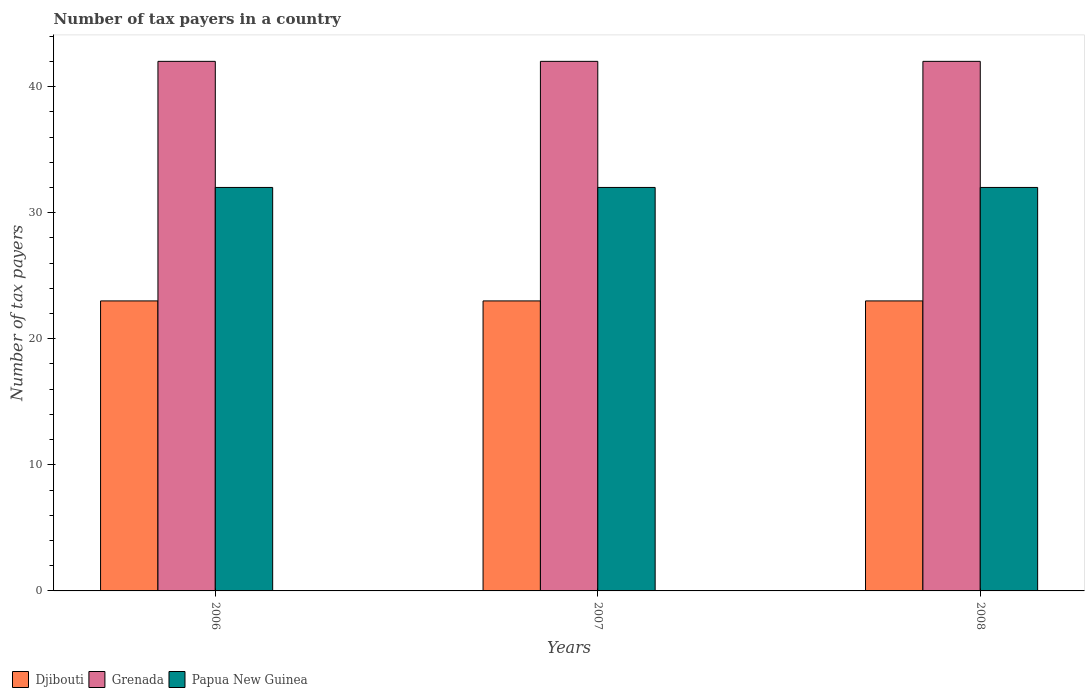How many different coloured bars are there?
Keep it short and to the point. 3. How many groups of bars are there?
Provide a short and direct response. 3. Are the number of bars per tick equal to the number of legend labels?
Offer a very short reply. Yes. Are the number of bars on each tick of the X-axis equal?
Keep it short and to the point. Yes. How many bars are there on the 3rd tick from the left?
Ensure brevity in your answer.  3. How many bars are there on the 1st tick from the right?
Make the answer very short. 3. In how many cases, is the number of bars for a given year not equal to the number of legend labels?
Provide a short and direct response. 0. What is the number of tax payers in in Djibouti in 2008?
Keep it short and to the point. 23. Across all years, what is the maximum number of tax payers in in Grenada?
Keep it short and to the point. 42. Across all years, what is the minimum number of tax payers in in Grenada?
Make the answer very short. 42. What is the total number of tax payers in in Papua New Guinea in the graph?
Ensure brevity in your answer.  96. What is the difference between the number of tax payers in in Grenada in 2008 and the number of tax payers in in Papua New Guinea in 2006?
Make the answer very short. 10. What is the average number of tax payers in in Papua New Guinea per year?
Provide a succinct answer. 32. In the year 2008, what is the difference between the number of tax payers in in Djibouti and number of tax payers in in Grenada?
Your response must be concise. -19. In how many years, is the number of tax payers in in Grenada greater than 42?
Offer a terse response. 0. What is the ratio of the number of tax payers in in Djibouti in 2006 to that in 2007?
Your response must be concise. 1. Is the difference between the number of tax payers in in Djibouti in 2007 and 2008 greater than the difference between the number of tax payers in in Grenada in 2007 and 2008?
Make the answer very short. No. What is the difference between the highest and the lowest number of tax payers in in Grenada?
Give a very brief answer. 0. What does the 3rd bar from the left in 2008 represents?
Offer a terse response. Papua New Guinea. What does the 1st bar from the right in 2006 represents?
Provide a succinct answer. Papua New Guinea. Is it the case that in every year, the sum of the number of tax payers in in Grenada and number of tax payers in in Djibouti is greater than the number of tax payers in in Papua New Guinea?
Make the answer very short. Yes. How many bars are there?
Keep it short and to the point. 9. Are all the bars in the graph horizontal?
Provide a short and direct response. No. Are the values on the major ticks of Y-axis written in scientific E-notation?
Make the answer very short. No. Where does the legend appear in the graph?
Keep it short and to the point. Bottom left. How many legend labels are there?
Your response must be concise. 3. What is the title of the graph?
Ensure brevity in your answer.  Number of tax payers in a country. What is the label or title of the Y-axis?
Provide a succinct answer. Number of tax payers. What is the Number of tax payers in Djibouti in 2006?
Provide a succinct answer. 23. What is the Number of tax payers in Grenada in 2006?
Offer a very short reply. 42. What is the Number of tax payers of Papua New Guinea in 2006?
Ensure brevity in your answer.  32. What is the Number of tax payers in Djibouti in 2007?
Provide a succinct answer. 23. What is the Number of tax payers of Papua New Guinea in 2007?
Ensure brevity in your answer.  32. What is the Number of tax payers in Djibouti in 2008?
Offer a terse response. 23. What is the Number of tax payers of Grenada in 2008?
Make the answer very short. 42. What is the Number of tax payers in Papua New Guinea in 2008?
Provide a short and direct response. 32. Across all years, what is the maximum Number of tax payers in Djibouti?
Keep it short and to the point. 23. Across all years, what is the maximum Number of tax payers in Grenada?
Offer a very short reply. 42. Across all years, what is the minimum Number of tax payers in Djibouti?
Your answer should be very brief. 23. Across all years, what is the minimum Number of tax payers in Grenada?
Offer a terse response. 42. What is the total Number of tax payers in Grenada in the graph?
Keep it short and to the point. 126. What is the total Number of tax payers in Papua New Guinea in the graph?
Give a very brief answer. 96. What is the difference between the Number of tax payers in Djibouti in 2006 and that in 2007?
Your response must be concise. 0. What is the difference between the Number of tax payers of Grenada in 2006 and that in 2007?
Offer a terse response. 0. What is the difference between the Number of tax payers in Djibouti in 2006 and that in 2008?
Your response must be concise. 0. What is the difference between the Number of tax payers of Grenada in 2006 and that in 2008?
Provide a short and direct response. 0. What is the difference between the Number of tax payers in Papua New Guinea in 2006 and that in 2008?
Provide a succinct answer. 0. What is the difference between the Number of tax payers of Papua New Guinea in 2007 and that in 2008?
Your answer should be compact. 0. What is the difference between the Number of tax payers of Djibouti in 2006 and the Number of tax payers of Grenada in 2007?
Give a very brief answer. -19. What is the difference between the Number of tax payers in Djibouti in 2006 and the Number of tax payers in Papua New Guinea in 2007?
Keep it short and to the point. -9. What is the difference between the Number of tax payers of Grenada in 2006 and the Number of tax payers of Papua New Guinea in 2007?
Keep it short and to the point. 10. What is the difference between the Number of tax payers of Djibouti in 2006 and the Number of tax payers of Grenada in 2008?
Your answer should be compact. -19. What is the difference between the Number of tax payers of Grenada in 2006 and the Number of tax payers of Papua New Guinea in 2008?
Offer a very short reply. 10. What is the average Number of tax payers in Papua New Guinea per year?
Your answer should be compact. 32. In the year 2006, what is the difference between the Number of tax payers of Djibouti and Number of tax payers of Grenada?
Your answer should be very brief. -19. In the year 2006, what is the difference between the Number of tax payers of Djibouti and Number of tax payers of Papua New Guinea?
Offer a very short reply. -9. In the year 2006, what is the difference between the Number of tax payers of Grenada and Number of tax payers of Papua New Guinea?
Keep it short and to the point. 10. In the year 2007, what is the difference between the Number of tax payers of Djibouti and Number of tax payers of Grenada?
Your response must be concise. -19. In the year 2007, what is the difference between the Number of tax payers of Grenada and Number of tax payers of Papua New Guinea?
Your response must be concise. 10. In the year 2008, what is the difference between the Number of tax payers in Grenada and Number of tax payers in Papua New Guinea?
Your response must be concise. 10. What is the ratio of the Number of tax payers in Djibouti in 2006 to that in 2007?
Offer a terse response. 1. What is the ratio of the Number of tax payers in Djibouti in 2006 to that in 2008?
Provide a short and direct response. 1. What is the ratio of the Number of tax payers of Grenada in 2006 to that in 2008?
Offer a very short reply. 1. What is the ratio of the Number of tax payers in Djibouti in 2007 to that in 2008?
Offer a terse response. 1. What is the difference between the highest and the second highest Number of tax payers in Djibouti?
Offer a terse response. 0. What is the difference between the highest and the second highest Number of tax payers of Grenada?
Offer a very short reply. 0. What is the difference between the highest and the second highest Number of tax payers in Papua New Guinea?
Your response must be concise. 0. What is the difference between the highest and the lowest Number of tax payers in Papua New Guinea?
Your answer should be very brief. 0. 